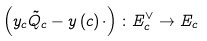<formula> <loc_0><loc_0><loc_500><loc_500>\left ( y _ { c } \tilde { Q } _ { c } - y \left ( c \right ) \cdot \right ) \colon E _ { c } ^ { \vee } \rightarrow E _ { c }</formula> 